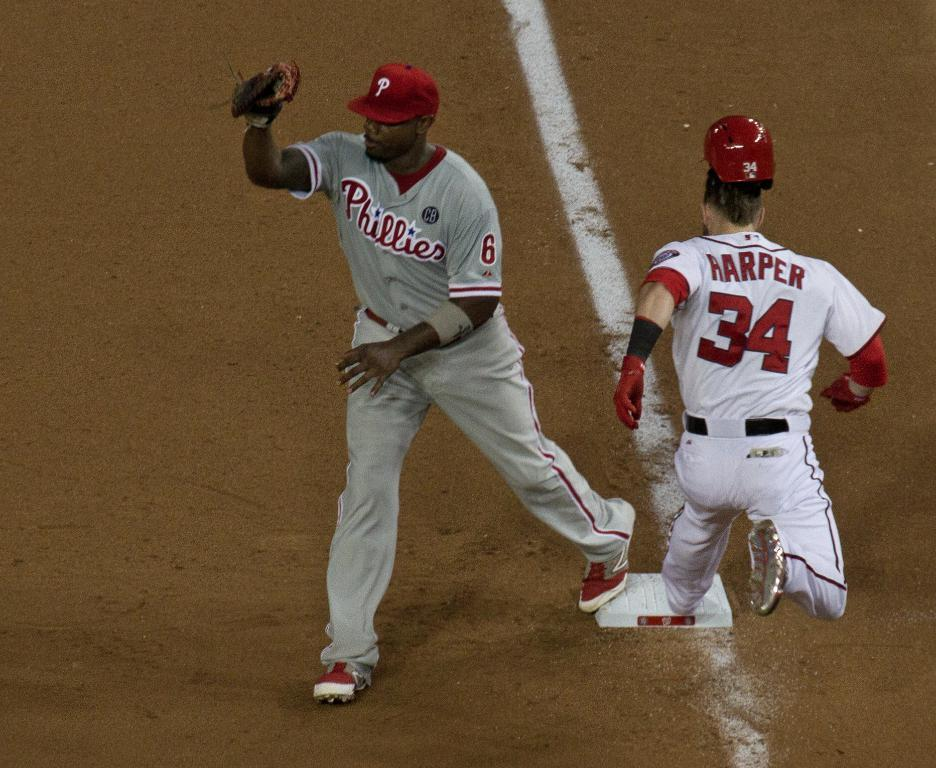<image>
Present a compact description of the photo's key features. Harper is number 34 and he's running to get onto the base. 